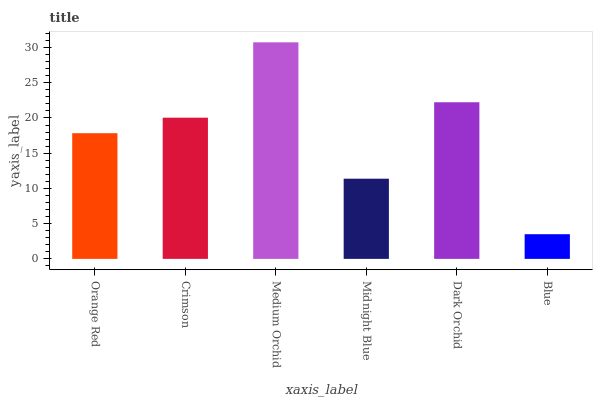Is Blue the minimum?
Answer yes or no. Yes. Is Medium Orchid the maximum?
Answer yes or no. Yes. Is Crimson the minimum?
Answer yes or no. No. Is Crimson the maximum?
Answer yes or no. No. Is Crimson greater than Orange Red?
Answer yes or no. Yes. Is Orange Red less than Crimson?
Answer yes or no. Yes. Is Orange Red greater than Crimson?
Answer yes or no. No. Is Crimson less than Orange Red?
Answer yes or no. No. Is Crimson the high median?
Answer yes or no. Yes. Is Orange Red the low median?
Answer yes or no. Yes. Is Medium Orchid the high median?
Answer yes or no. No. Is Dark Orchid the low median?
Answer yes or no. No. 